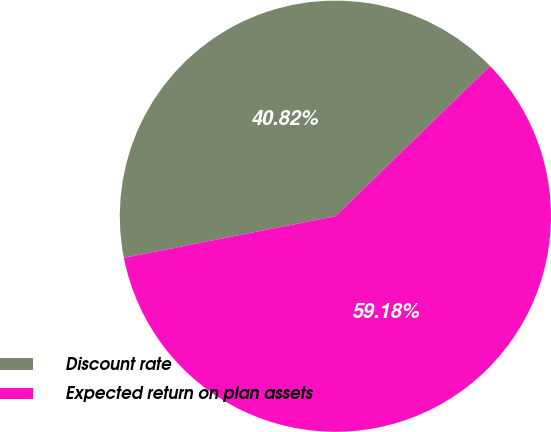Convert chart to OTSL. <chart><loc_0><loc_0><loc_500><loc_500><pie_chart><fcel>Discount rate<fcel>Expected return on plan assets<nl><fcel>40.82%<fcel>59.18%<nl></chart> 